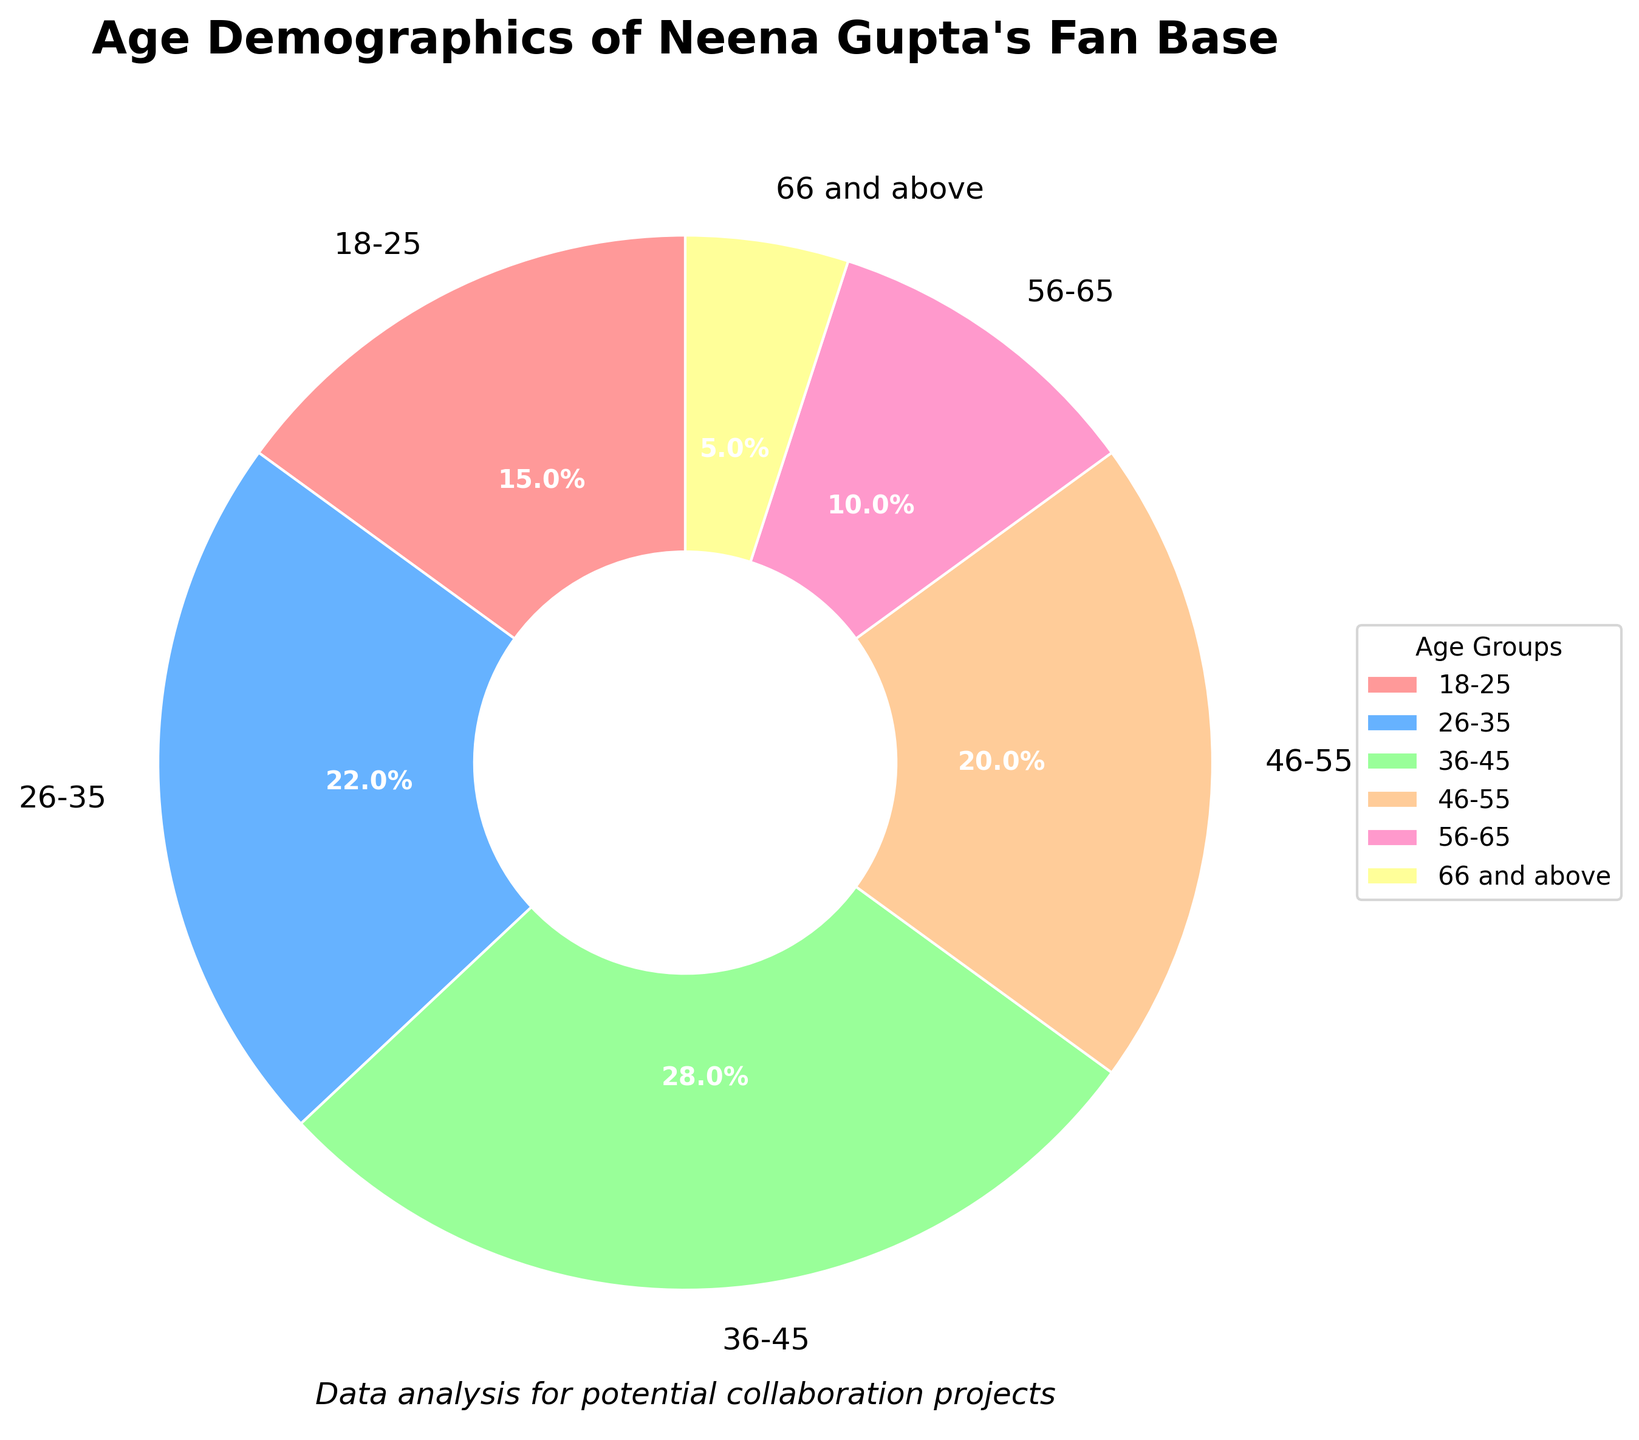What percentage of Neena Gupta's fan base is aged 36-45? The pie chart shows the percentage values for different age groups. Looking at the label for the 36-45 age group, it shows 28%.
Answer: 28% Which age group has the smallest percentage of Neena Gupta's fan base? The pie chart shows the percentage values for different age groups. The smallest percentage visible is for the 66 and above age group, which is 5%.
Answer: 66 and above How much larger is the 36-45 age group compared to the 18-25 age group? The 36-45 age group has 28% while the 18-25 age group has 15%. The difference can be calculated as 28% - 15% = 13%.
Answer: 13% What is the total percentage of Neena Gupta's fan base that is aged 26-35 and 36-45? To find the total percentage for these two groups, add their percentages: 22% (26-35) + 28% (36-45) = 50%.
Answer: 50% Which age group has the highest percentage of Neena Gupta's fan base? The pie chart indicates the various percentages, and the 36-45 age group has the highest percentage at 28%.
Answer: 36-45 Are there more fans aged 46-55 or 56-65, and by how much? From the pie chart, the 46-55 age group has 20% and the 56-65 age group has 10%. The difference is 20% - 10% = 10%.
Answer: 46-55 by 10% What is the sum of the percentages for the age groups under 46 years old? Add up the percentages for the 18-25, 26-35, and 36-45 groups: 15% + 22% + 28% = 65%.
Answer: 65% How do the percentages of the 18-25 and 56-65 age groups compare visually in terms of size? The slice for the 18-25 age group appears larger than the 56-65 slice. The 18-25 group is 15% while the 56-65 group is 10%, and thus the 18-25 slice covers more area in the chart.
Answer: 18-25 is larger Which color represents the 66 and above age group in the pie chart? The visual attributes of the pie chart use different colors for each segment, and the color corresponding to the 66 and above group is yellow based on the pie chart’s color arrangement.
Answer: Yellow 